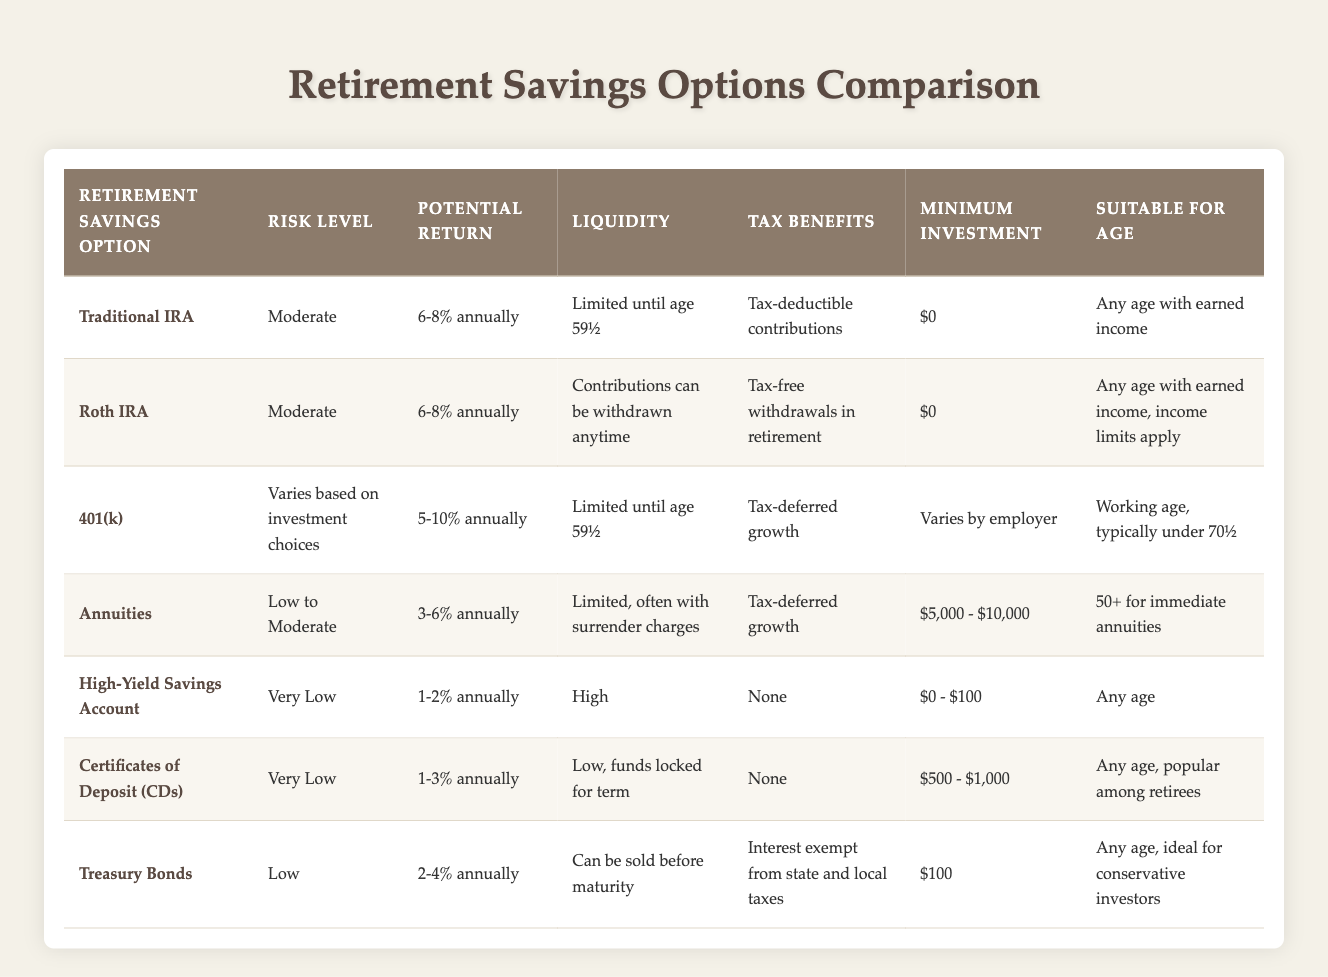What is the minimum investment required for a Traditional IRA? The table clearly states that the minimum investment for a Traditional IRA is $0.
Answer: $0 What are the tax benefits associated with Roth IRAs? According to the table, Roth IRAs offer tax-free withdrawals in retirement as their tax benefit.
Answer: Tax-free withdrawals in retirement Which option has the highest potential return? Comparing the potential returns, the 401(k) offers 5-10% annually, which is the highest among all listed options.
Answer: 5-10% annually (401(k)) Is liquidity high for High-Yield Savings Accounts? Yes, the table indicates that High-Yield Savings Accounts have high liquidity, allowing easy access to funds.
Answer: Yes What is the average potential return of the options suitable for seniors aged 50 and above? The suitable options for this age group are Annuities (3-6%), and comparing it with Treasury Bonds (2-4%), we take the averages: Annuities average is (3+6)/2 = 4.5% and Treasury Bonds average is (2+4)/2 = 3%. Thus, the overall average is (4.5 + 3)/2 = 3.75%.
Answer: 3.75% How many options have a risk level classified as low or very low? From the table, there are three options with a risk level of low (Treasury Bonds) or very low (High-Yield Savings Account and CDs). Therefore, there are three options in total.
Answer: Three options Is it true that all retirement savings options have zero minimum investment? No, not all options have a minimum investment of $0. The Annuities require a minimum investment between $5,000 and $10,000, while others like CDs ask for at least $500.
Answer: No What is the liquidity status of Certificates of Deposit? The table indicates that the liquidity for Certificates of Deposit (CDs) is low, as funds are locked for a specified term.
Answer: Low What investment option is suitable for any age with earned income? The table lists both Traditional IRA and Roth IRA as suitable for any age with earned income, indicating that either can fit this criterion.
Answer: Traditional IRA and Roth IRA 